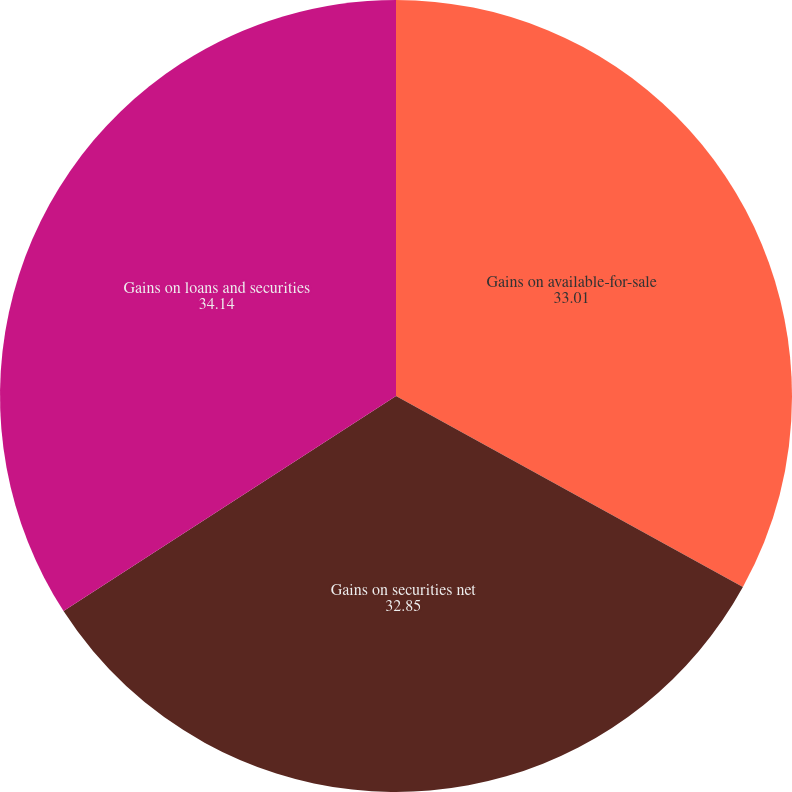Convert chart to OTSL. <chart><loc_0><loc_0><loc_500><loc_500><pie_chart><fcel>Gains on available-for-sale<fcel>Gains on securities net<fcel>Gains on loans and securities<nl><fcel>33.01%<fcel>32.85%<fcel>34.14%<nl></chart> 